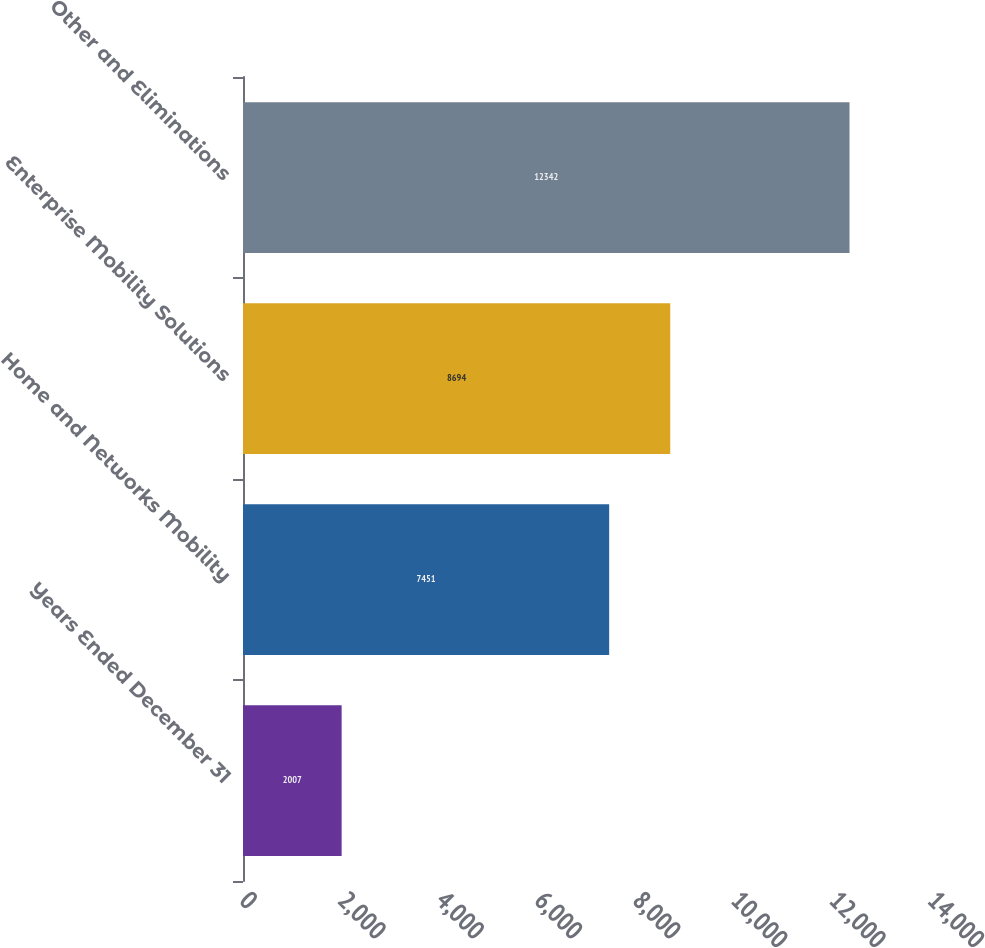Convert chart. <chart><loc_0><loc_0><loc_500><loc_500><bar_chart><fcel>Years Ended December 31<fcel>Home and Networks Mobility<fcel>Enterprise Mobility Solutions<fcel>Other and Eliminations<nl><fcel>2007<fcel>7451<fcel>8694<fcel>12342<nl></chart> 